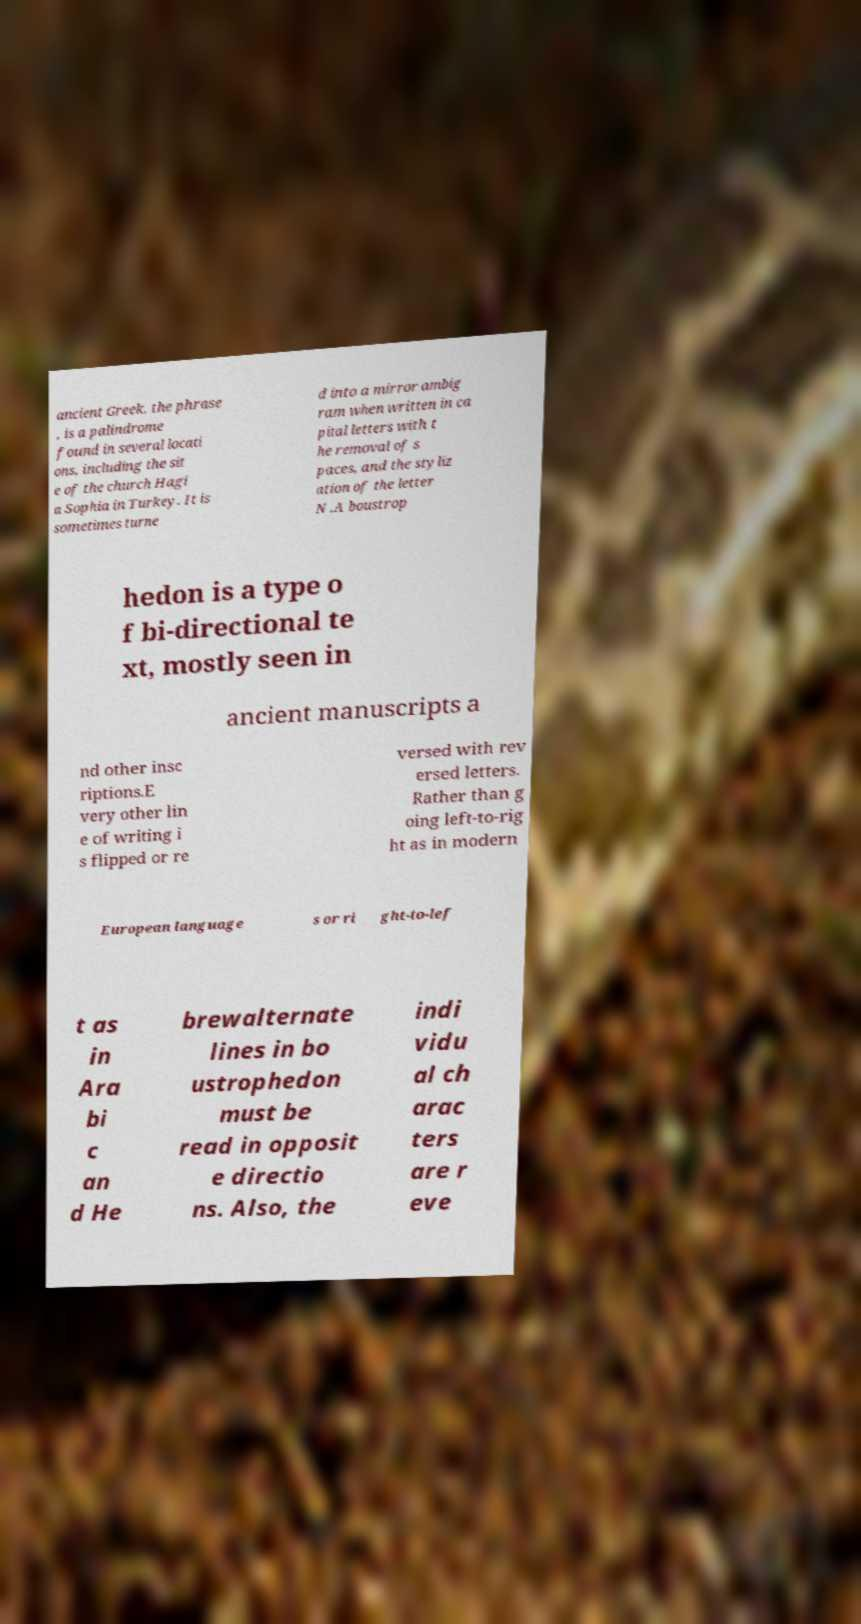Could you extract and type out the text from this image? ancient Greek, the phrase , is a palindrome found in several locati ons, including the sit e of the church Hagi a Sophia in Turkey. It is sometimes turne d into a mirror ambig ram when written in ca pital letters with t he removal of s paces, and the styliz ation of the letter N .A boustrop hedon is a type o f bi-directional te xt, mostly seen in ancient manuscripts a nd other insc riptions.E very other lin e of writing i s flipped or re versed with rev ersed letters. Rather than g oing left-to-rig ht as in modern European language s or ri ght-to-lef t as in Ara bi c an d He brewalternate lines in bo ustrophedon must be read in opposit e directio ns. Also, the indi vidu al ch arac ters are r eve 